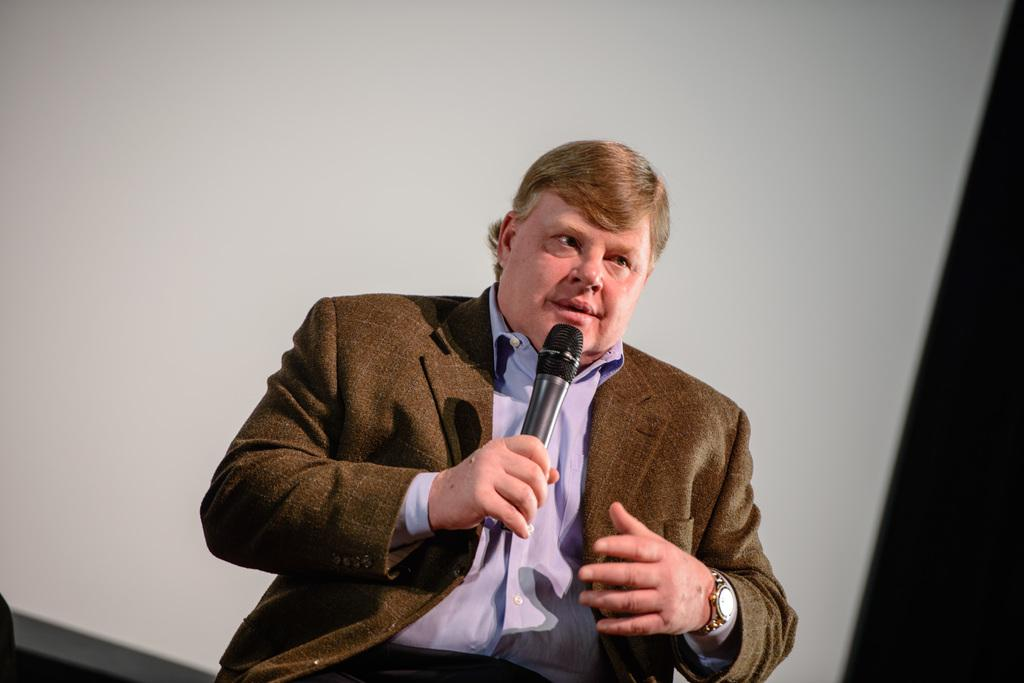Who is the main subject in the image? There is a man in the image. What is the man doing in the image? The man is speaking in the image. How is the man holding the microphone? The man is holding the microphone with his right hand. What color is the coal in the image? There is no coal present in the image. How does the man sneeze while holding the microphone? The man is not sneezing in the image; he is speaking. 